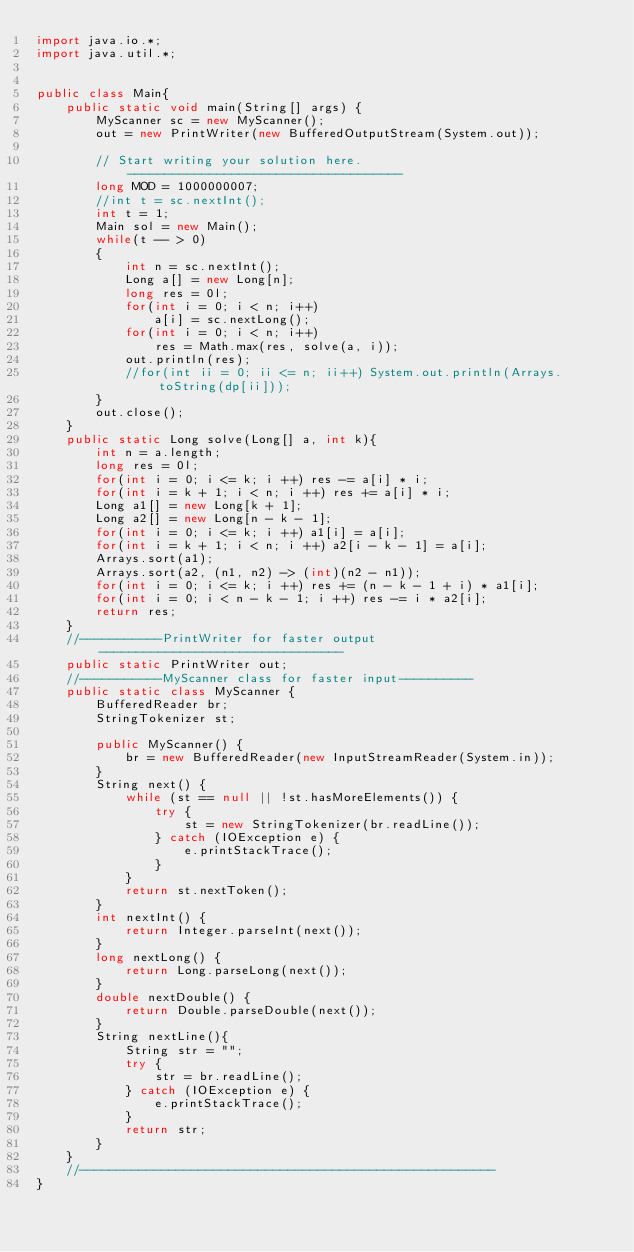<code> <loc_0><loc_0><loc_500><loc_500><_Java_>import java.io.*;
import java.util.*;


public class Main{
    public static void main(String[] args) {
        MyScanner sc = new MyScanner();
        out = new PrintWriter(new BufferedOutputStream(System.out));

        // Start writing your solution here. -------------------------------------
        long MOD = 1000000007;
        //int t = sc.nextInt();
        int t = 1;
        Main sol = new Main();
        while(t -- > 0)
        {
            int n = sc.nextInt();
            Long a[] = new Long[n];
            long res = 0l;
            for(int i = 0; i < n; i++)
                a[i] = sc.nextLong();
            for(int i = 0; i < n; i++)
                res = Math.max(res, solve(a, i));
            out.println(res);
            //for(int ii = 0; ii <= n; ii++) System.out.println(Arrays.toString(dp[ii]));
        }
        out.close();
    }
    public static Long solve(Long[] a, int k){
        int n = a.length;
        long res = 0l;
        for(int i = 0; i <= k; i ++) res -= a[i] * i;
        for(int i = k + 1; i < n; i ++) res += a[i] * i;
        Long a1[] = new Long[k + 1];
        Long a2[] = new Long[n - k - 1];
        for(int i = 0; i <= k; i ++) a1[i] = a[i];
        for(int i = k + 1; i < n; i ++) a2[i - k - 1] = a[i];
        Arrays.sort(a1);
        Arrays.sort(a2, (n1, n2) -> (int)(n2 - n1));
        for(int i = 0; i <= k; i ++) res += (n - k - 1 + i) * a1[i];
        for(int i = 0; i < n - k - 1; i ++) res -= i * a2[i];
        return res;
    }
    //-----------PrintWriter for faster output---------------------------------
    public static PrintWriter out;
    //-----------MyScanner class for faster input----------
    public static class MyScanner {
        BufferedReader br;
        StringTokenizer st;

        public MyScanner() {
            br = new BufferedReader(new InputStreamReader(System.in));
        }
        String next() {
            while (st == null || !st.hasMoreElements()) {
                try {
                    st = new StringTokenizer(br.readLine());
                } catch (IOException e) {
                    e.printStackTrace();
                }
            }
            return st.nextToken();
        }
        int nextInt() {
            return Integer.parseInt(next());
        }
        long nextLong() {
            return Long.parseLong(next());
        }
        double nextDouble() {
            return Double.parseDouble(next());
        }
        String nextLine(){
            String str = "";
            try {
                str = br.readLine();
            } catch (IOException e) {
                e.printStackTrace();
            }
            return str;
        }
    }
    //--------------------------------------------------------
}</code> 